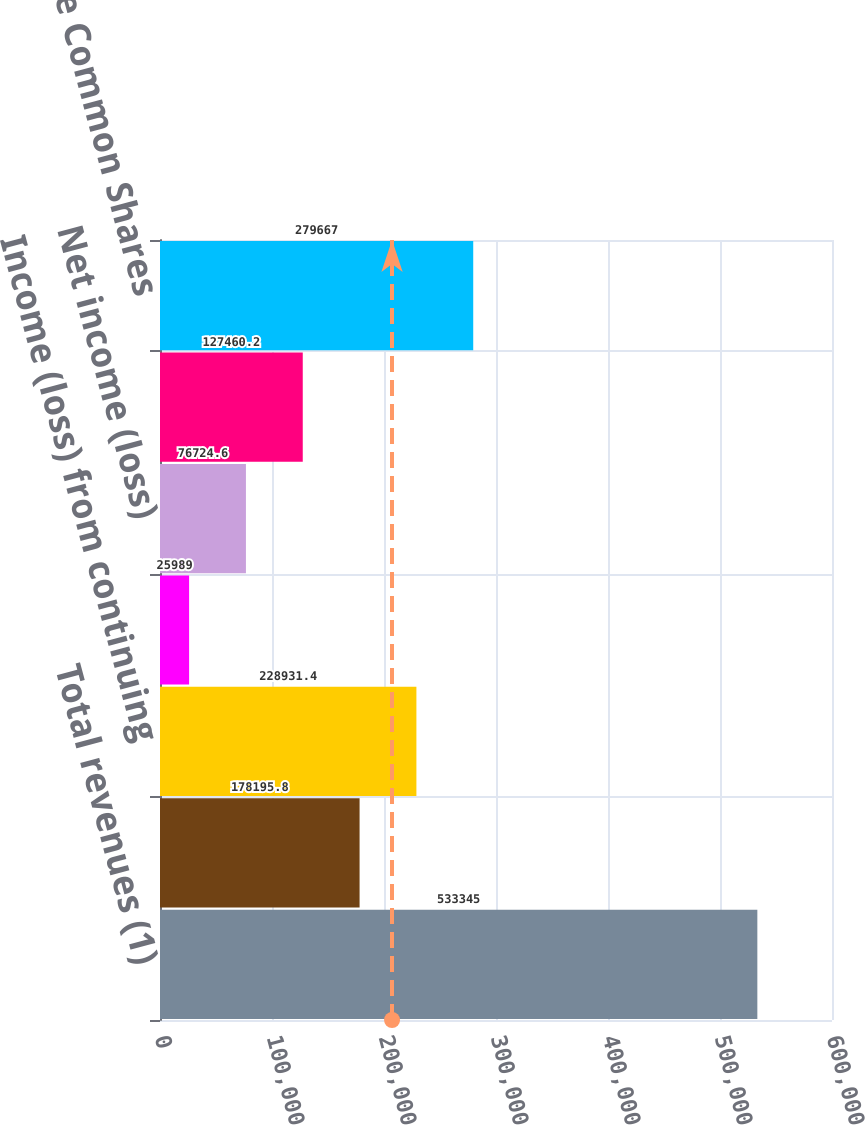<chart> <loc_0><loc_0><loc_500><loc_500><bar_chart><fcel>Total revenues (1)<fcel>Operating income (1)<fcel>Income (loss) from continuing<fcel>Discontinued operations net of<fcel>Net income (loss)<fcel>Net income (loss) available to<fcel>Weighted average Common Shares<nl><fcel>533345<fcel>178196<fcel>228931<fcel>25989<fcel>76724.6<fcel>127460<fcel>279667<nl></chart> 